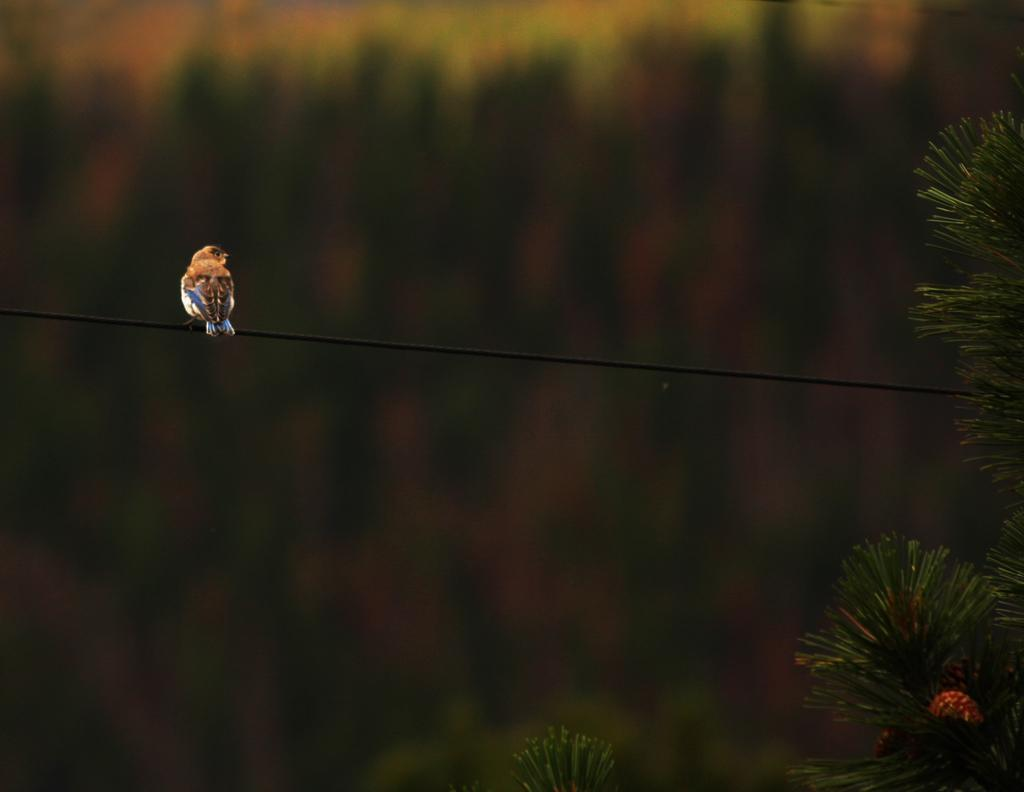What type of animal can be seen in the image? There is a bird in the image. Where is the bird located? The bird is on a cable. What can be seen in the background of the image? There are trees in the background of the image. What type of appliance is the bird using to communicate in the image? There is no appliance present in the image, and the bird is not using any device to communicate. 